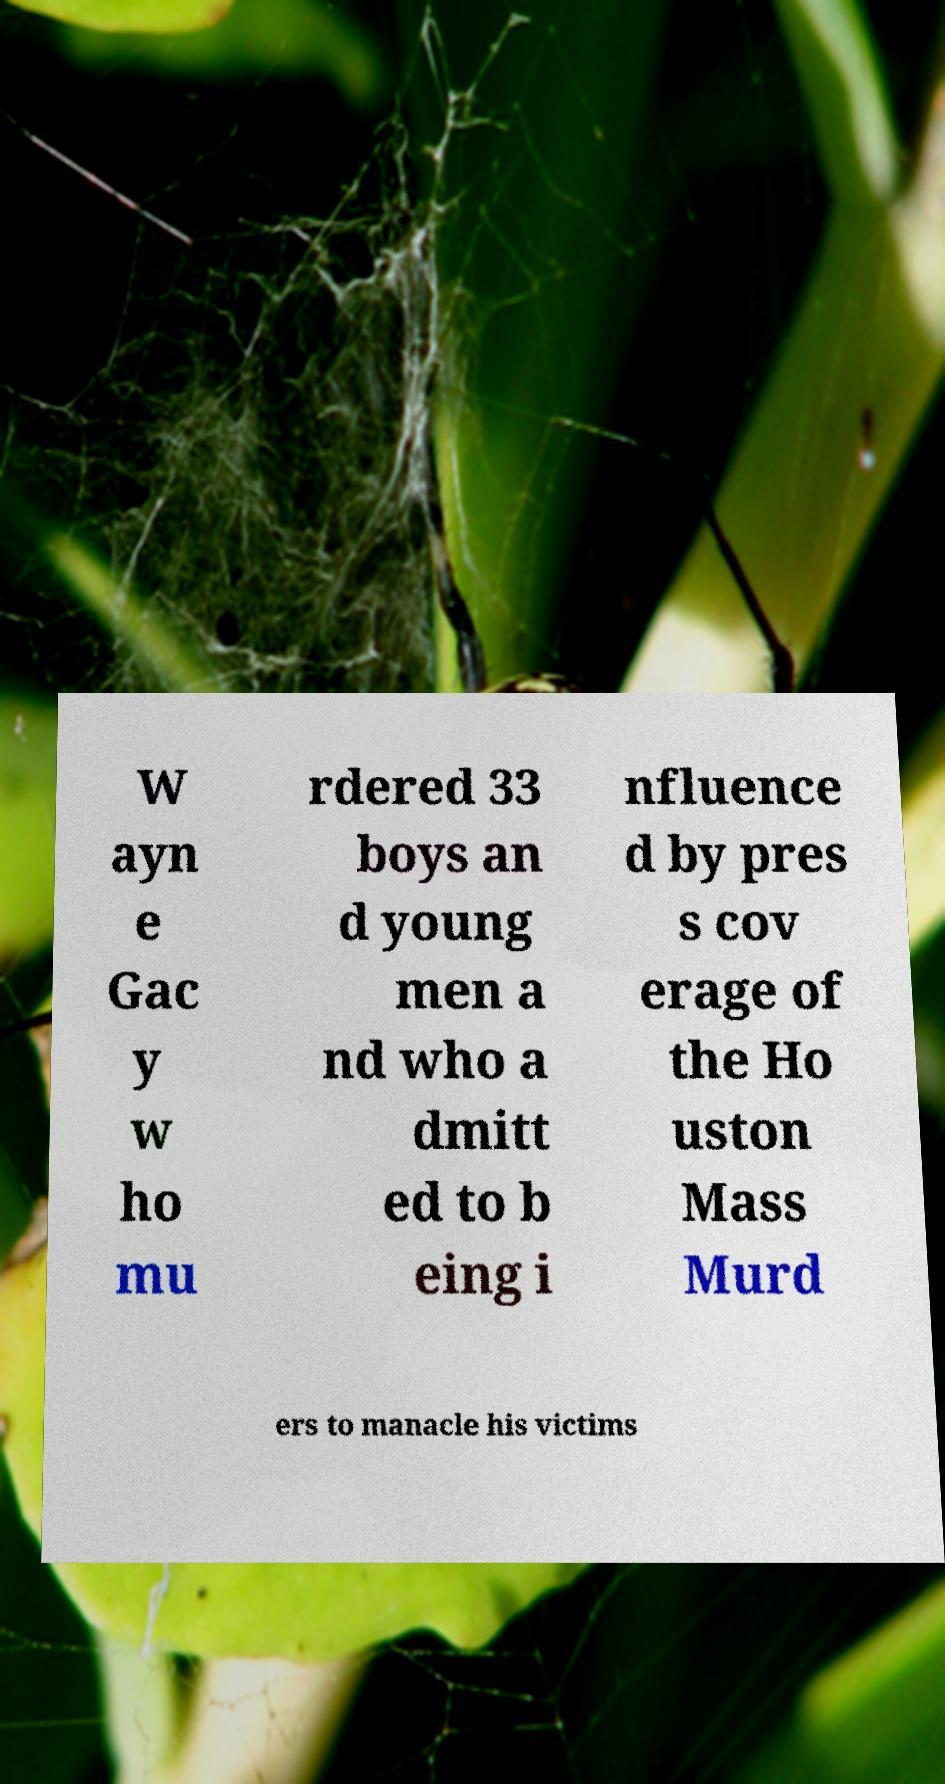I need the written content from this picture converted into text. Can you do that? W ayn e Gac y w ho mu rdered 33 boys an d young men a nd who a dmitt ed to b eing i nfluence d by pres s cov erage of the Ho uston Mass Murd ers to manacle his victims 